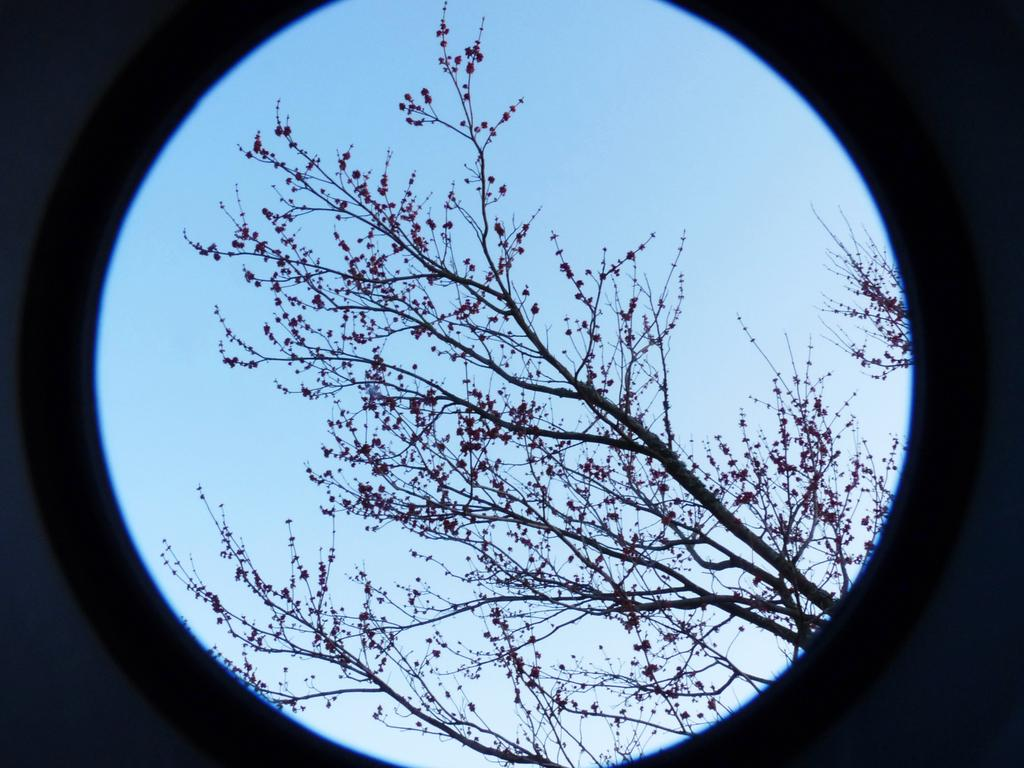What is the main subject of the image? The main subject of the image is a camera lens. What can be seen through the camera lens? Trees are visible through the camera lens. What additional detail can be observed about the trees? The trees have flowers. What else is visible in the image besides the trees? There is sky visible in the image. How long does it take for the minute hand to stop moving in the image? There is no clock or minute hand present in the image, so it is not possible to determine how long it takes for the minute hand to stop moving. 